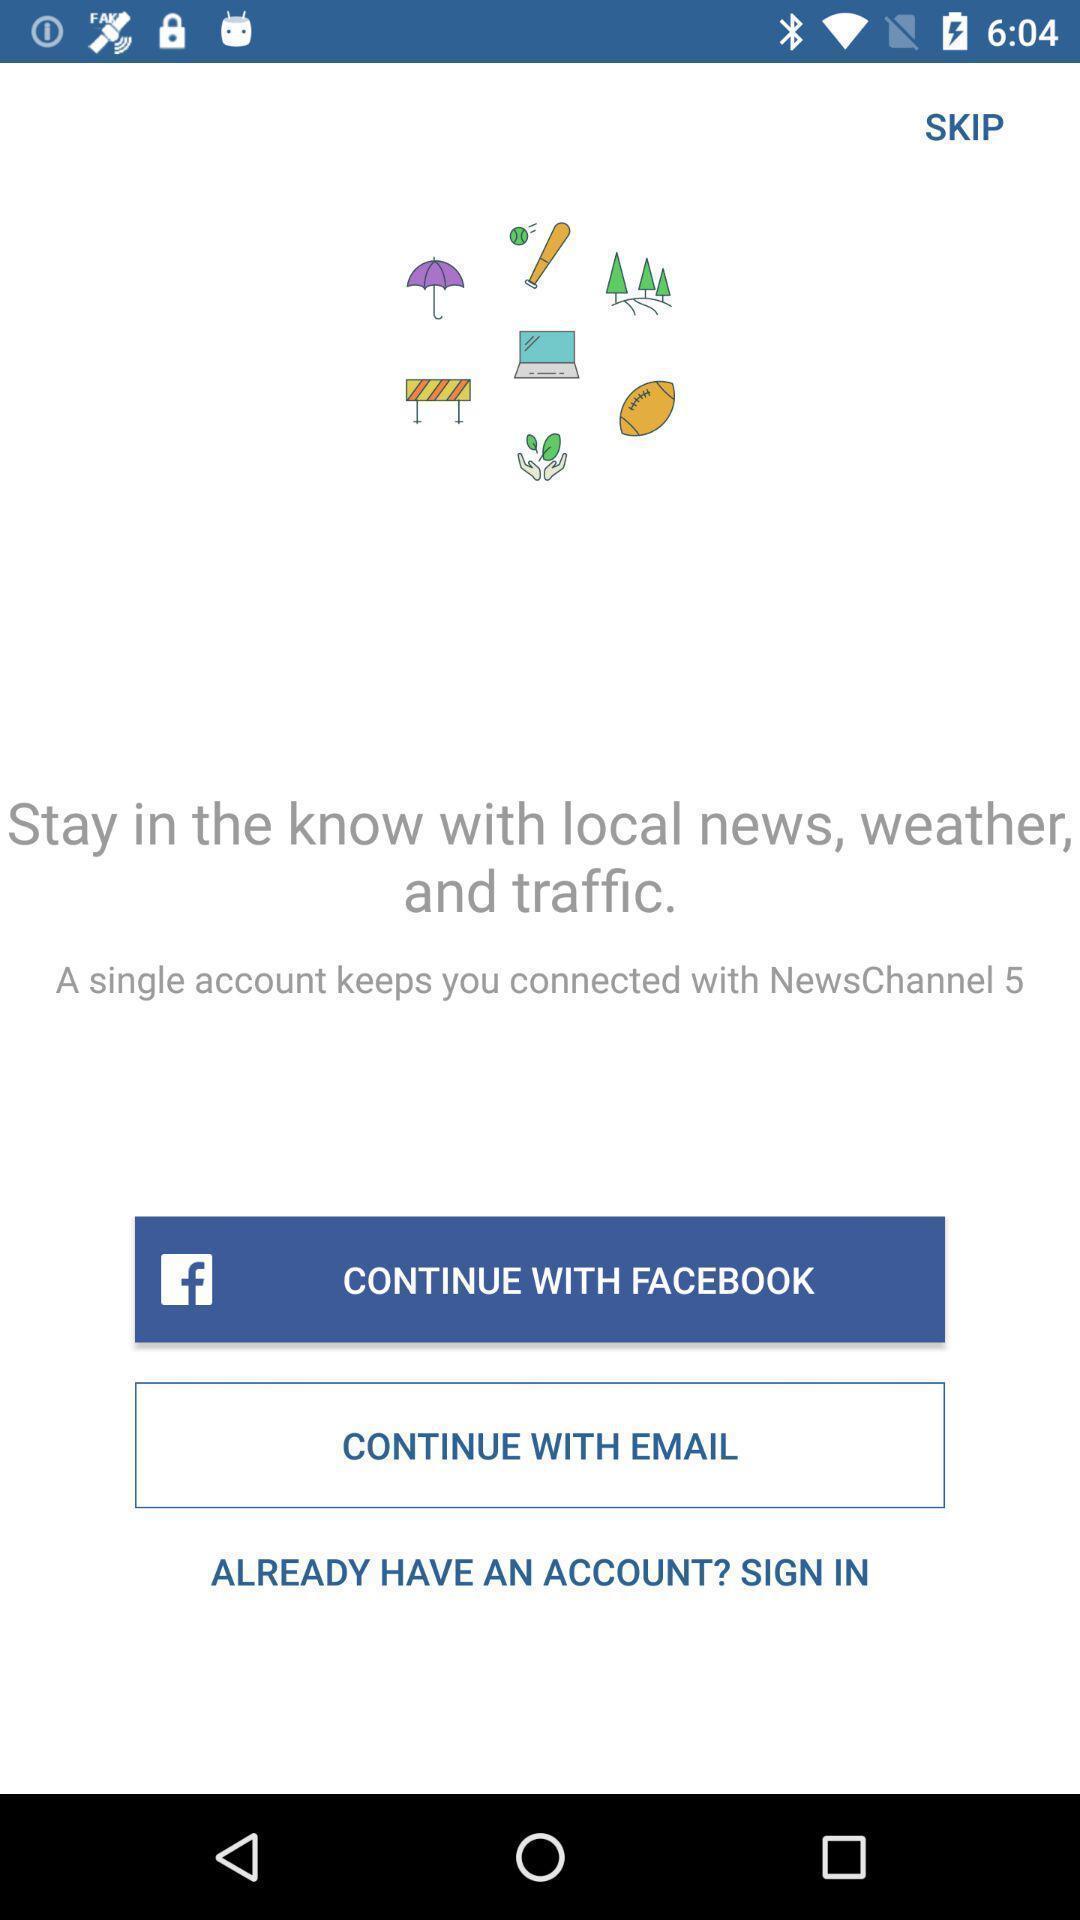Describe this image in words. Sign in page in a news app. 